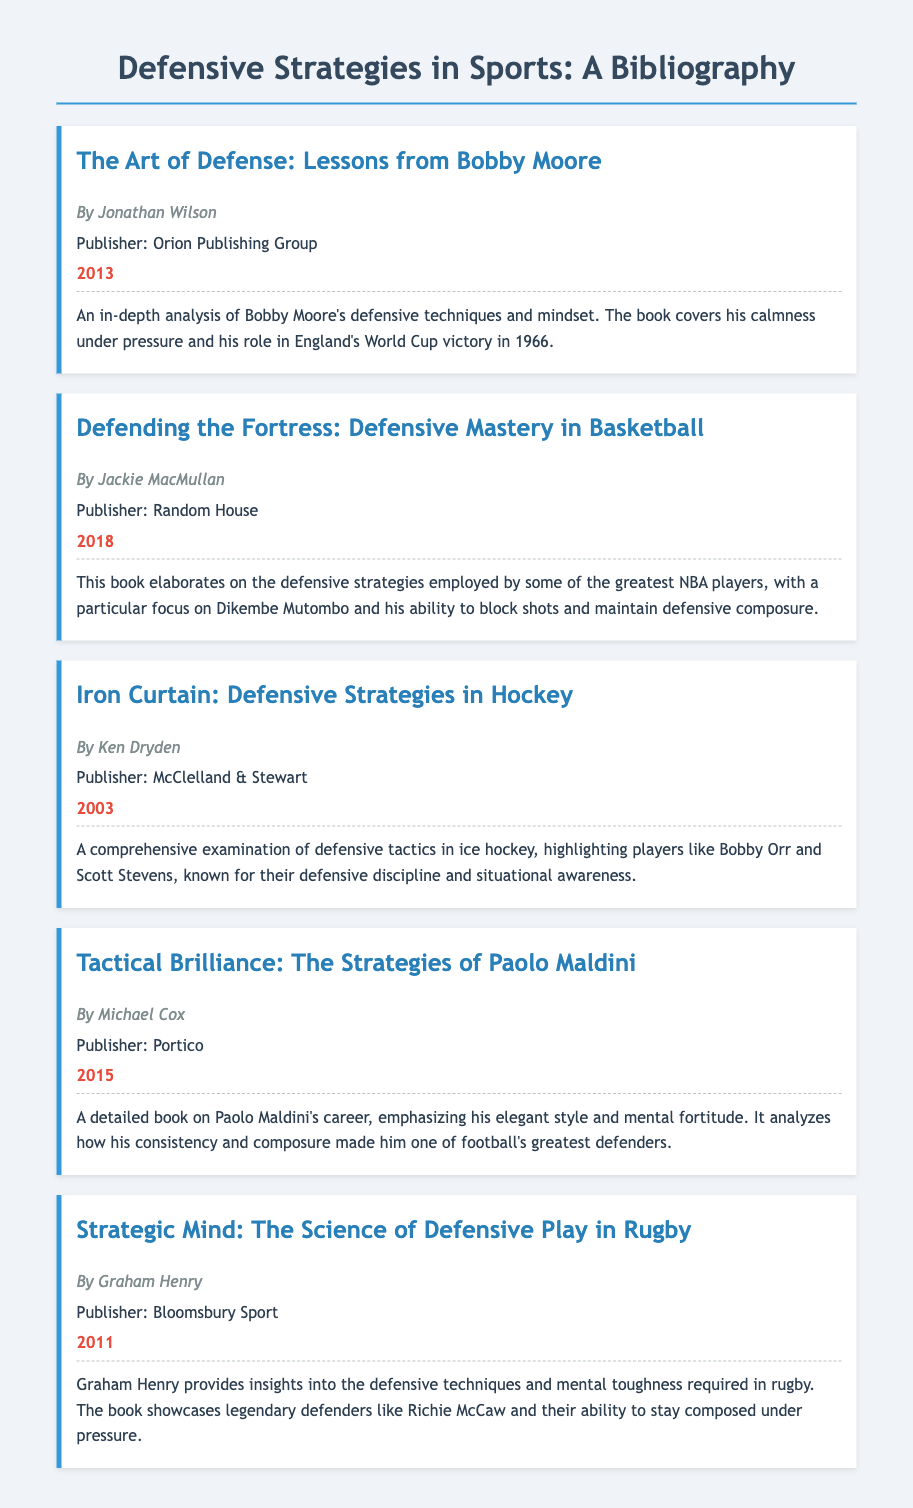What is the title of the book by Jonathan Wilson? The title is specifically mentioned in the document under his bibliography entry.
Answer: The Art of Defense: Lessons from Bobby Moore Who is the author of "Defending the Fortress: Defensive Mastery in Basketball"? The author is clearly stated in the bibliography for that particular entry.
Answer: Jackie MacMullan In what year was "Iron Curtain: Defensive Strategies in Hockey" published? The publication year is provided in the entry for the book.
Answer: 2003 Which defensive player is highlighted in “Strategic Mind: The Science of Defensive Play in Rugby”? The entry includes the name of the legendary defender featured in the book.
Answer: Richie McCaw What is the primary focus of the book "Tactical Brilliance: The Strategies of Paolo Maldini"? The description gives insight into the main theme of the book.
Answer: His elegant style and mental fortitude Which publisher released "The Art of Defense: Lessons from Bobby Moore"? The publisher's name is specified in the bibliography entry for this book.
Answer: Orion Publishing Group What defensive strategy is emphasized in Jackie MacMullan's book? The description of the book explains its central theme regarding defensive strategies.
Answer: Blocking shots Which book discusses Bobbie Moore’s involvement in a notable football event? The description details the specific event in which Bobby Moore participated.
Answer: England's World Cup victory in 1966 